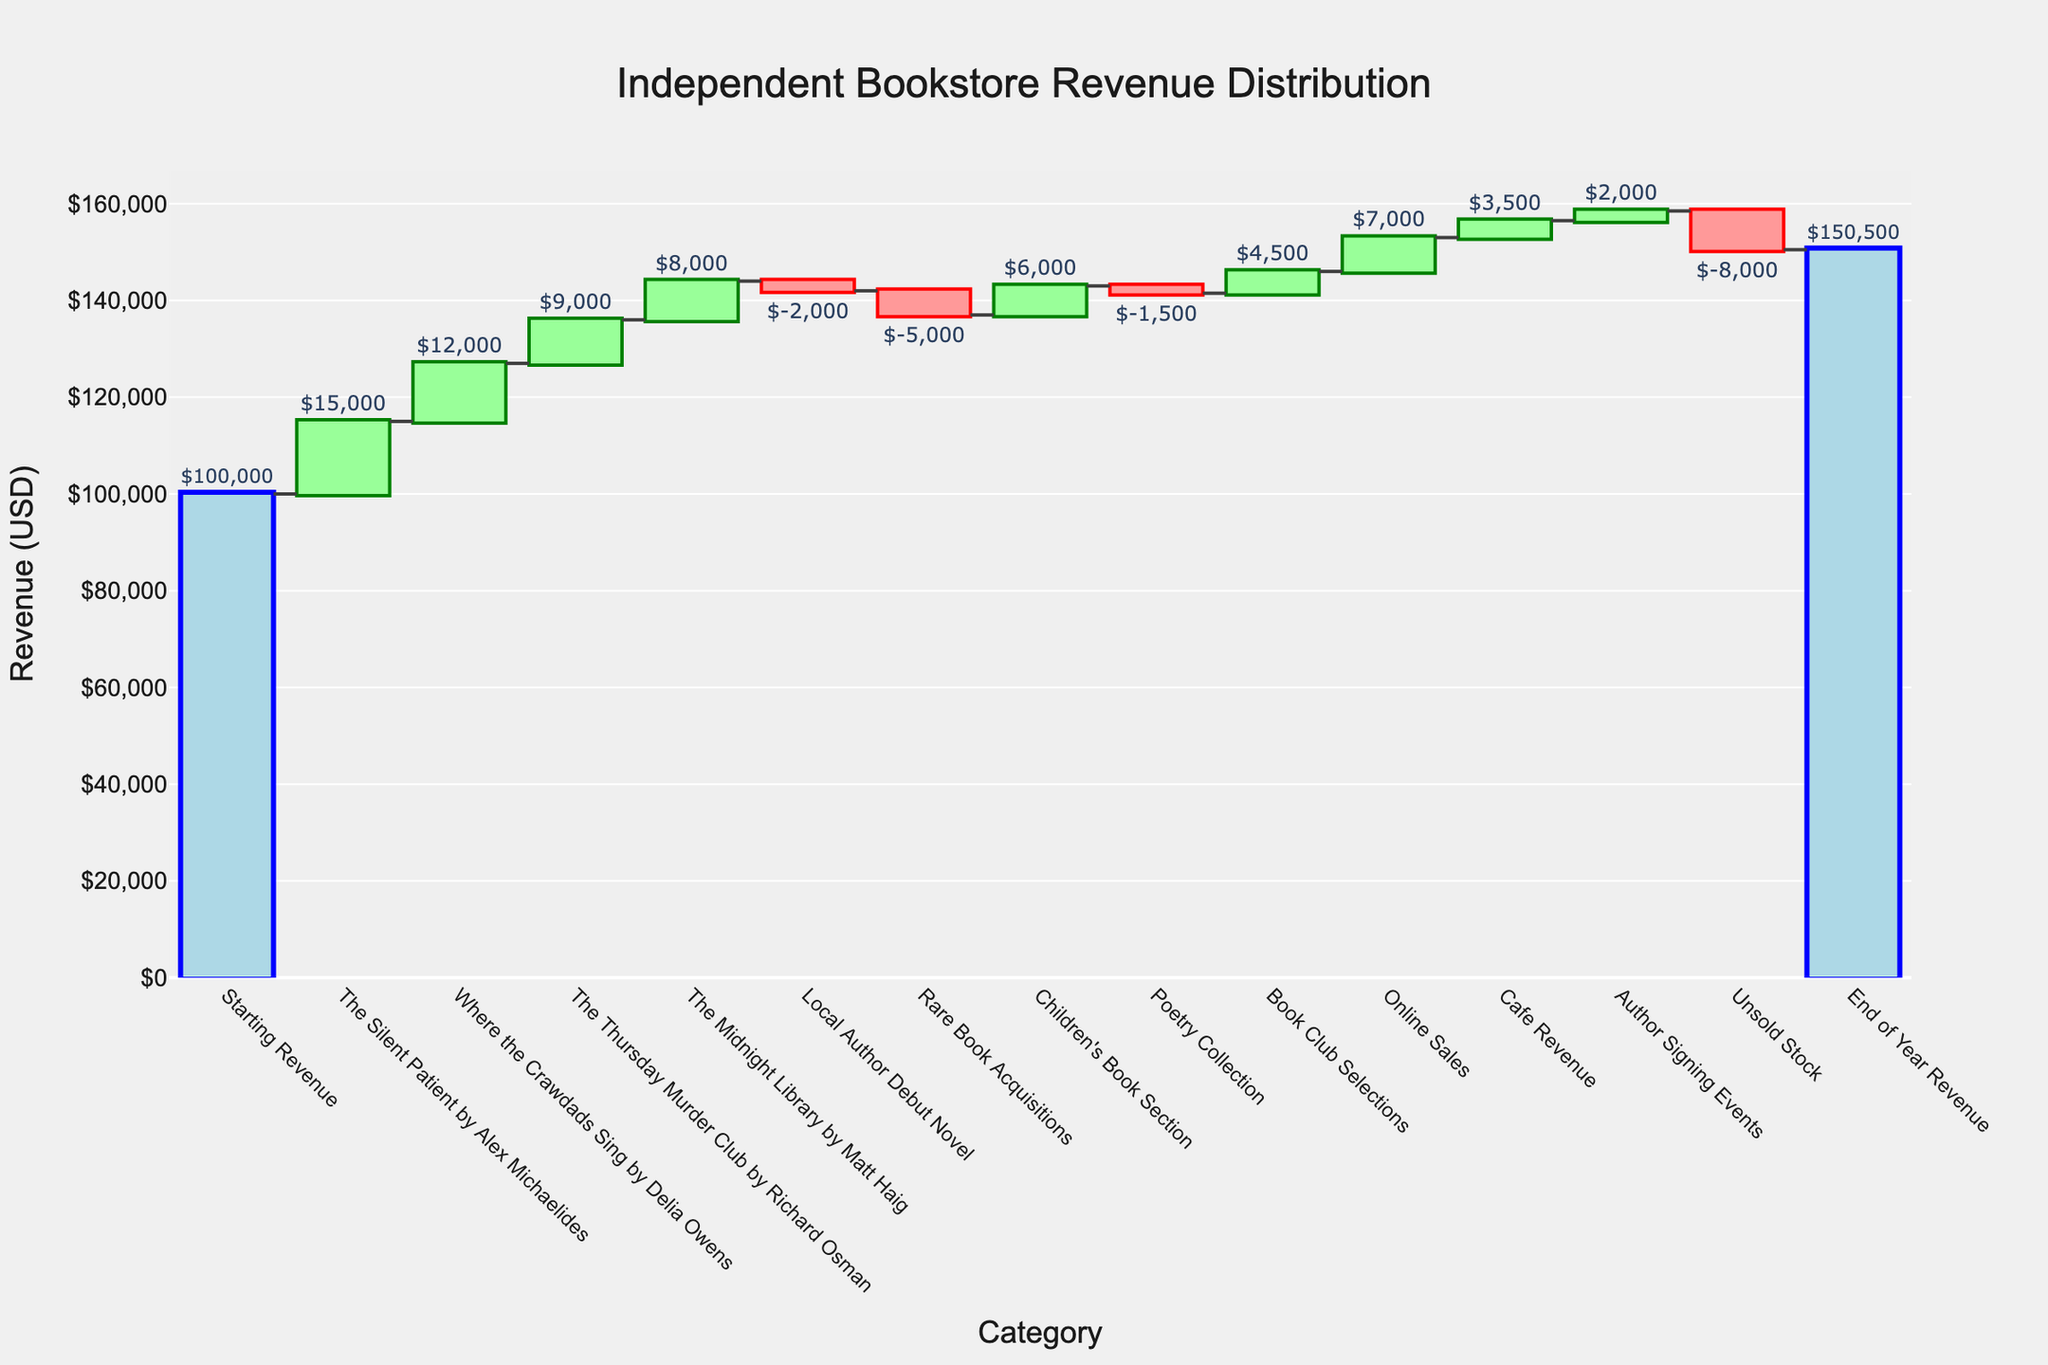What's the overall trend in the bookstore's revenue throughout the year? The figure starts with a 'Starting Revenue' of $100,000 and ends with an 'End of Year Revenue' of $150,500. This indicates an overall positive trend in revenue.
Answer: Positive Which category contributed the highest revenue? "The Silent Patient" by Alex Michaelides contributed $15,000, which is the highest single positive addition to revenue.
Answer: "The Silent Patient" by Alex Michaelides Which category had the most significant negative impact on revenue? 'Unsold Stock' had a value of -$8,000, making it the category with the most significant negative impact on revenue.
Answer: Unsold Stock What's the total revenue impact of the bestsellers combined? Adding the revenue from the bestsellers: $15,000 (The Silent Patient) + $12,000 (Where the Crawdads Sing) + $9,000 (The Thursday Murder Club) + $8,000 (The Midnight Library), we get $44,000.
Answer: $44,000 How much did the 'Local Author Debut Novel' and 'Rare Book Acquisitions' categories reduce the revenue in total? Adding the negative values: -$2,000 (Local Author Debut Novel) + -$5,000 (Rare Book Acquisitions), the total reduction is -$7,000.
Answer: -$7,000 Did 'Online Sales' generate more revenue than 'Cafe Revenue'? Yes, 'Online Sales' generated $7,000 while 'Cafe Revenue' generated $3,500. Therefore, 'Online Sales' generated more revenue.
Answer: Yes What is the net impact of the 'Author Signing Events' and 'Children's Book Section' combined? Adding the values of both categories: $2,000 (Author Signing Events) + $6,000 (Children's Book Section), the net impact is $8,000.
Answer: $8,000 What was the bookstore's final revenue for the year? The final revenue, labeled 'End of Year Revenue,' is $150,500.
Answer: $150,500 What's the difference in revenue contributions between the 'Poetry Collection' and 'Book Club Selections'? 'Book Club Selections' added $4,500 while 'Poetry Collection' reduced revenue by -$1,500. The difference is $4,500 - (-$1,500) = $6,000.
Answer: $6,000 Which category between 'Children's Book Section' and 'Book Club Selections' contributed more to the revenue? The 'Children's Book Section' added $6,000 while 'Book Club Selections' added $4,500. Thus, 'Children's Book Section' contributed more.
Answer: Children's Book Section 